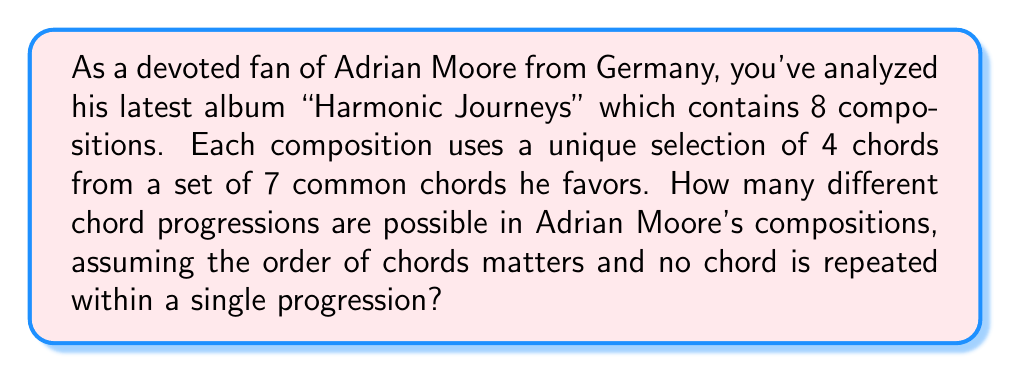Can you solve this math problem? To solve this problem, we need to use the concept of permutations without repetition. Here's how we can approach it:

1. We have 7 chords to choose from for each position in the 4-chord progression.
2. For the first chord, we have 7 choices.
3. For the second chord, we have 6 choices (since we can't repeat).
4. For the third chord, we have 5 choices.
5. For the fourth chord, we have 4 choices.

This scenario is a perfect application of the permutation formula:

$$ P(n,r) = \frac{n!}{(n-r)!} $$

Where $n$ is the total number of items to choose from (7 chords), and $r$ is the number of items being chosen (4 chords in each progression).

Plugging in our values:

$$ P(7,4) = \frac{7!}{(7-4)!} = \frac{7!}{3!} $$

Let's calculate this:

$$ \frac{7 * 6 * 5 * 4 * 3!}{3!} = 7 * 6 * 5 * 4 = 840 $$

Therefore, there are 840 possible unique chord progressions in Adrian Moore's compositions.
Answer: 840 unique chord progressions 